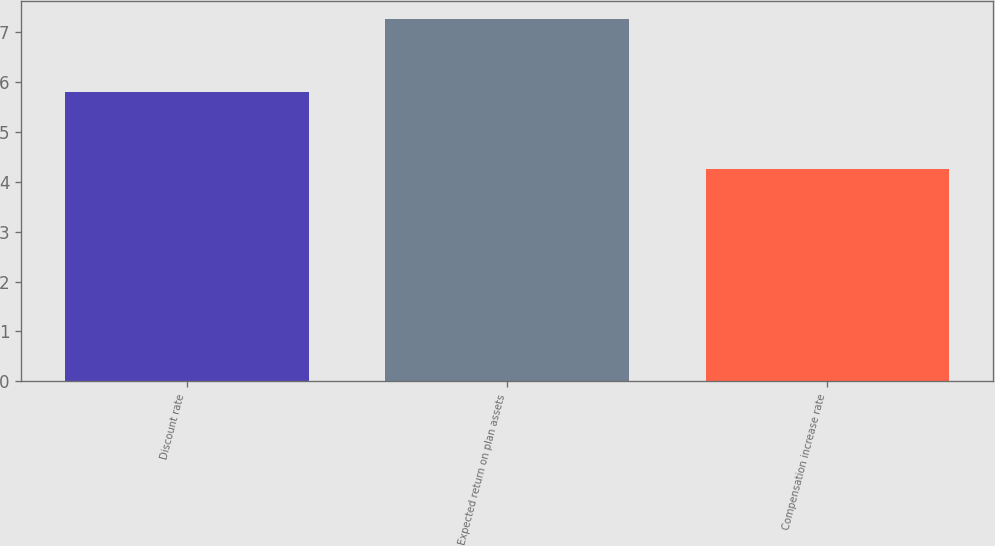Convert chart. <chart><loc_0><loc_0><loc_500><loc_500><bar_chart><fcel>Discount rate<fcel>Expected return on plan assets<fcel>Compensation increase rate<nl><fcel>5.8<fcel>7.25<fcel>4.25<nl></chart> 